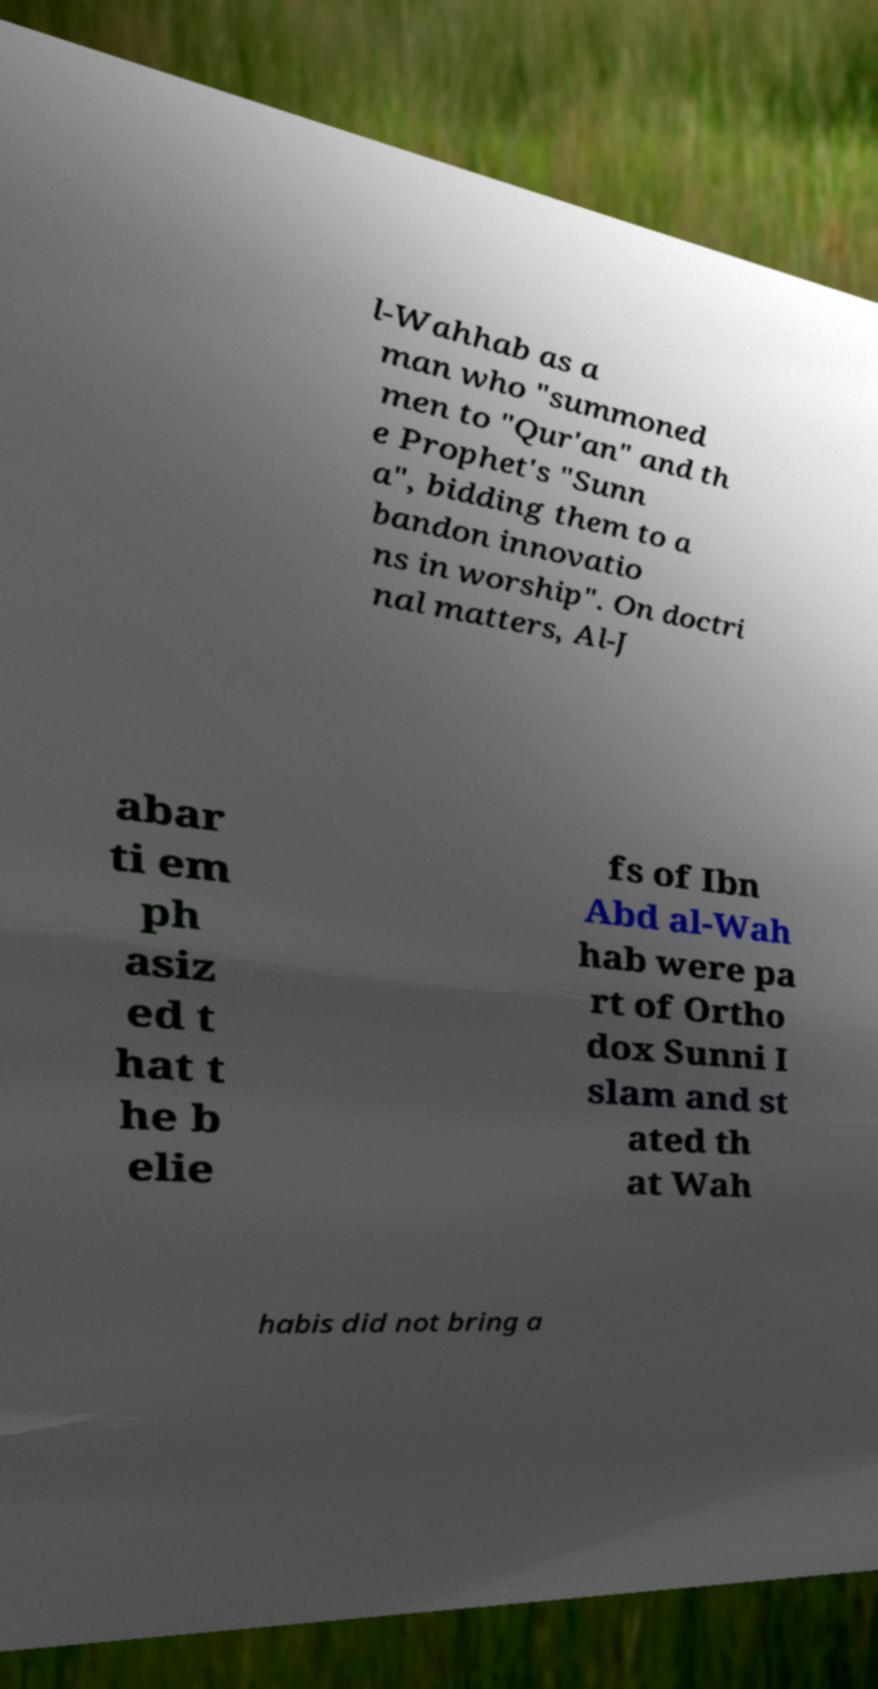Please identify and transcribe the text found in this image. l-Wahhab as a man who "summoned men to "Qur'an" and th e Prophet's "Sunn a", bidding them to a bandon innovatio ns in worship". On doctri nal matters, Al-J abar ti em ph asiz ed t hat t he b elie fs of Ibn Abd al-Wah hab were pa rt of Ortho dox Sunni I slam and st ated th at Wah habis did not bring a 